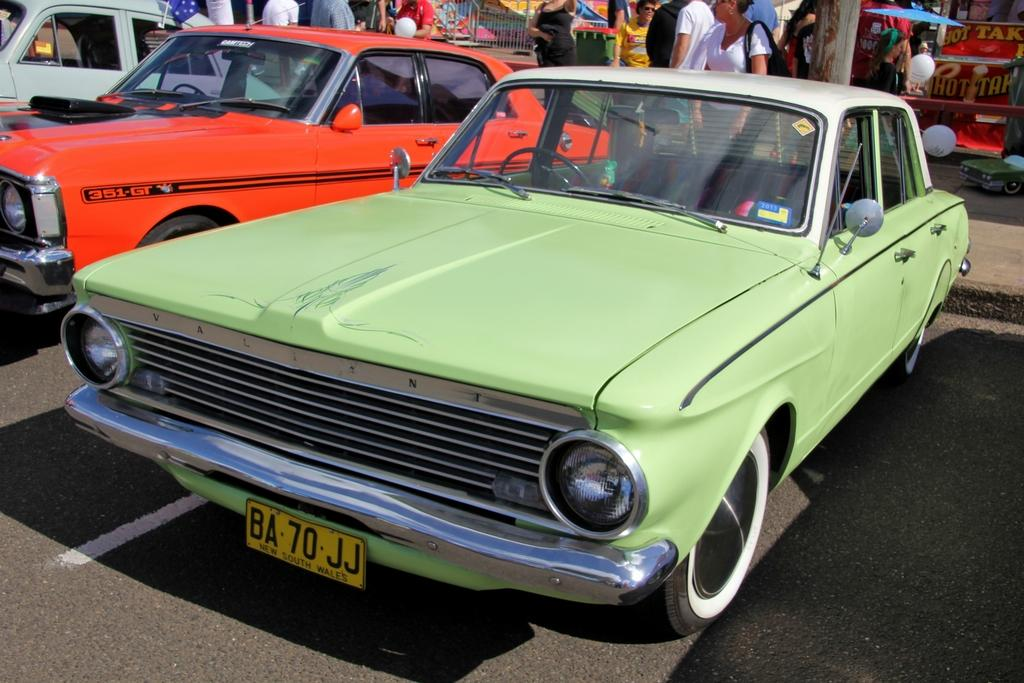What can be seen on the road in the image? There are vehicles on the road in the image. What features do the vehicles have? The vehicles have number plates and wheels. What can be seen in the background of the image? There are people, a grill, an umbrella, balloons, and a stall in the background. How many scarves are being sold at the stall in the image? There is no mention of scarves being sold at the stall in the image. What type of bell can be heard ringing in the background of the image? There is no bell present or audible in the image. 